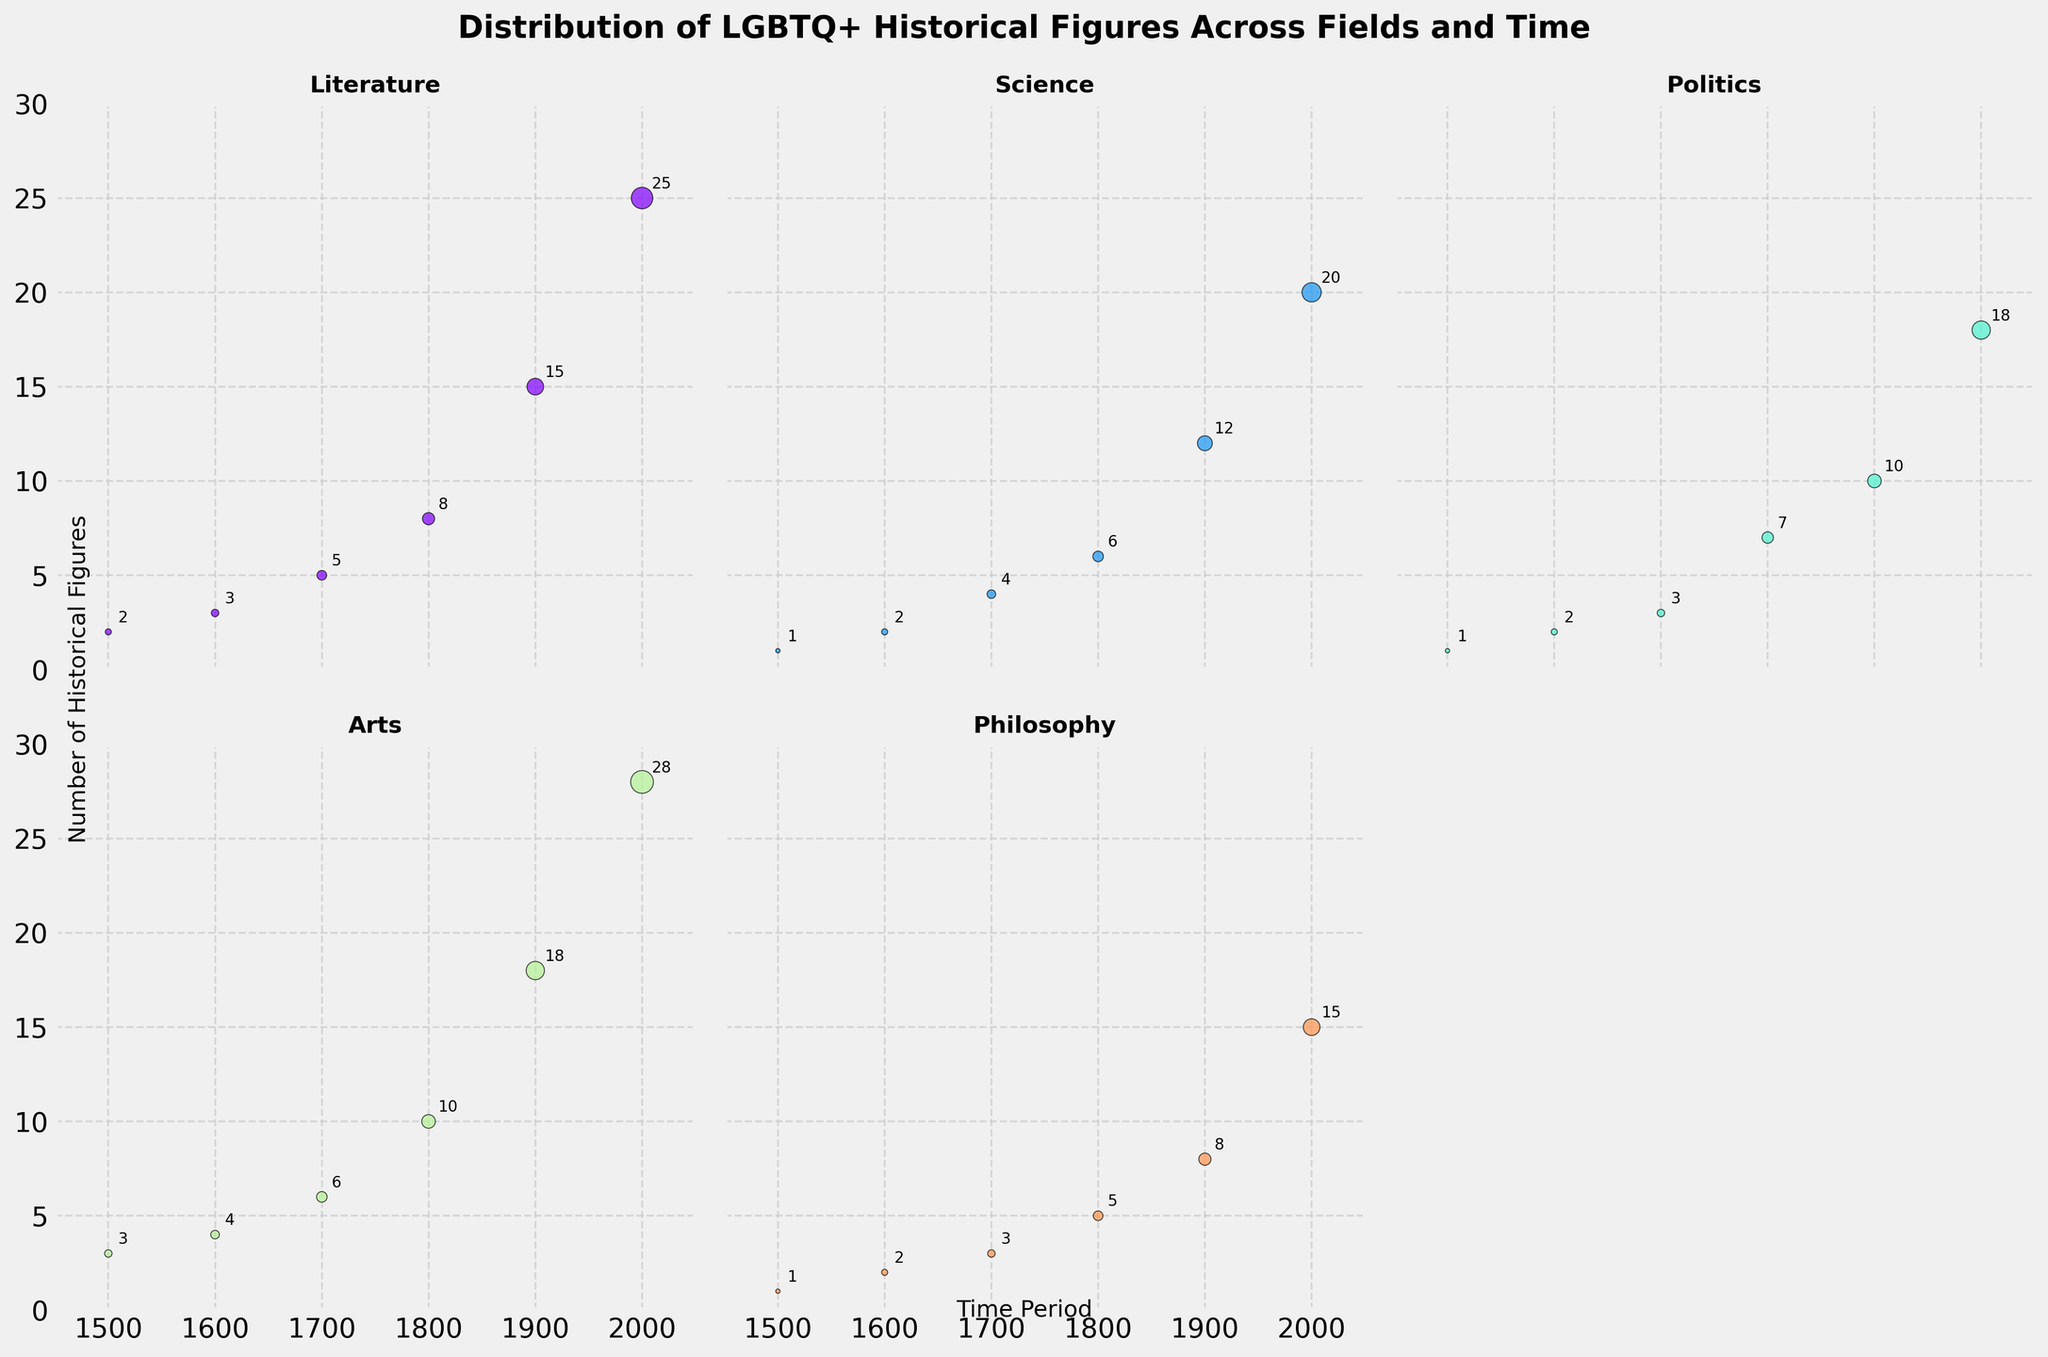How many LGBTQ+ historical figures are recorded in the field of Arts in 1700? The subplot for Arts shows a scatter point at the year 1700 with a number label. The label next to the point indicates the number of figures.
Answer: 6 Which field has the highest number of LGBTQ+ historical figures in 2000? Look at the subplots for all fields and find the scatter point for the year 2000 with the highest label. The subplot for Arts has the highest label for 2000.
Answer: Arts How does the number of LGBTQ+ historical figures in Philosophy in 1800 compare to the number in Military in 1800? Check the 1800 scatter points in the Philosophy and Military subplots. The labels will show the numbers.
Answer: Philosophy has more figures than Military Which field saw the highest increase in LGBTQ+ historical figures from 1500 to 2000? Calculate the difference in the number of figures from 1500 to 2000 for each field and compare them. Arts has the largest increase from 3 in 1500 to 28 in 2000, which is an increase of 25 figures.
Answer: Arts What is the total number of LGBTQ+ historical figures recorded in Science across all time periods? Sum the number of figures across all time periods in the Science subplot: 1+2+4+6+12+20 = 45.
Answer: 45 What is the average number of LGBTQ+ historical figures in Politics over the recorded time periods? Calculate the average by summing the figures and dividing by the number of periods: (1+2+3+7+10+18)/6 = 41/6 ≈ 6.83.
Answer: ∼6.83 Are there any fields where the number of figures stays consistent or fluctuates minimally? Examine all subplots and focus on the consistency or fluctuations of the scatter points across time periods.
Answer: No, all fields show significant changes How does the distribution trend of LGBTQ+ figures in Literature compare to that in Science from 1500 to 2000? Compare the trend lines of numbers across the time periods in both subplots. Both show an increasing trend, but Literature has a higher final count in 2000 (25 vs. Science's 20).
Answer: Both increase, Literature peaks higher Which field shows the earliest record of LGBTQ+ historical figures, and what is the number? Identify the earliest (smallest) time period in which scatter points appear in the subplots. Literature and Arts both have records starting in 1500.
Answer: Literature and Arts, 1500 